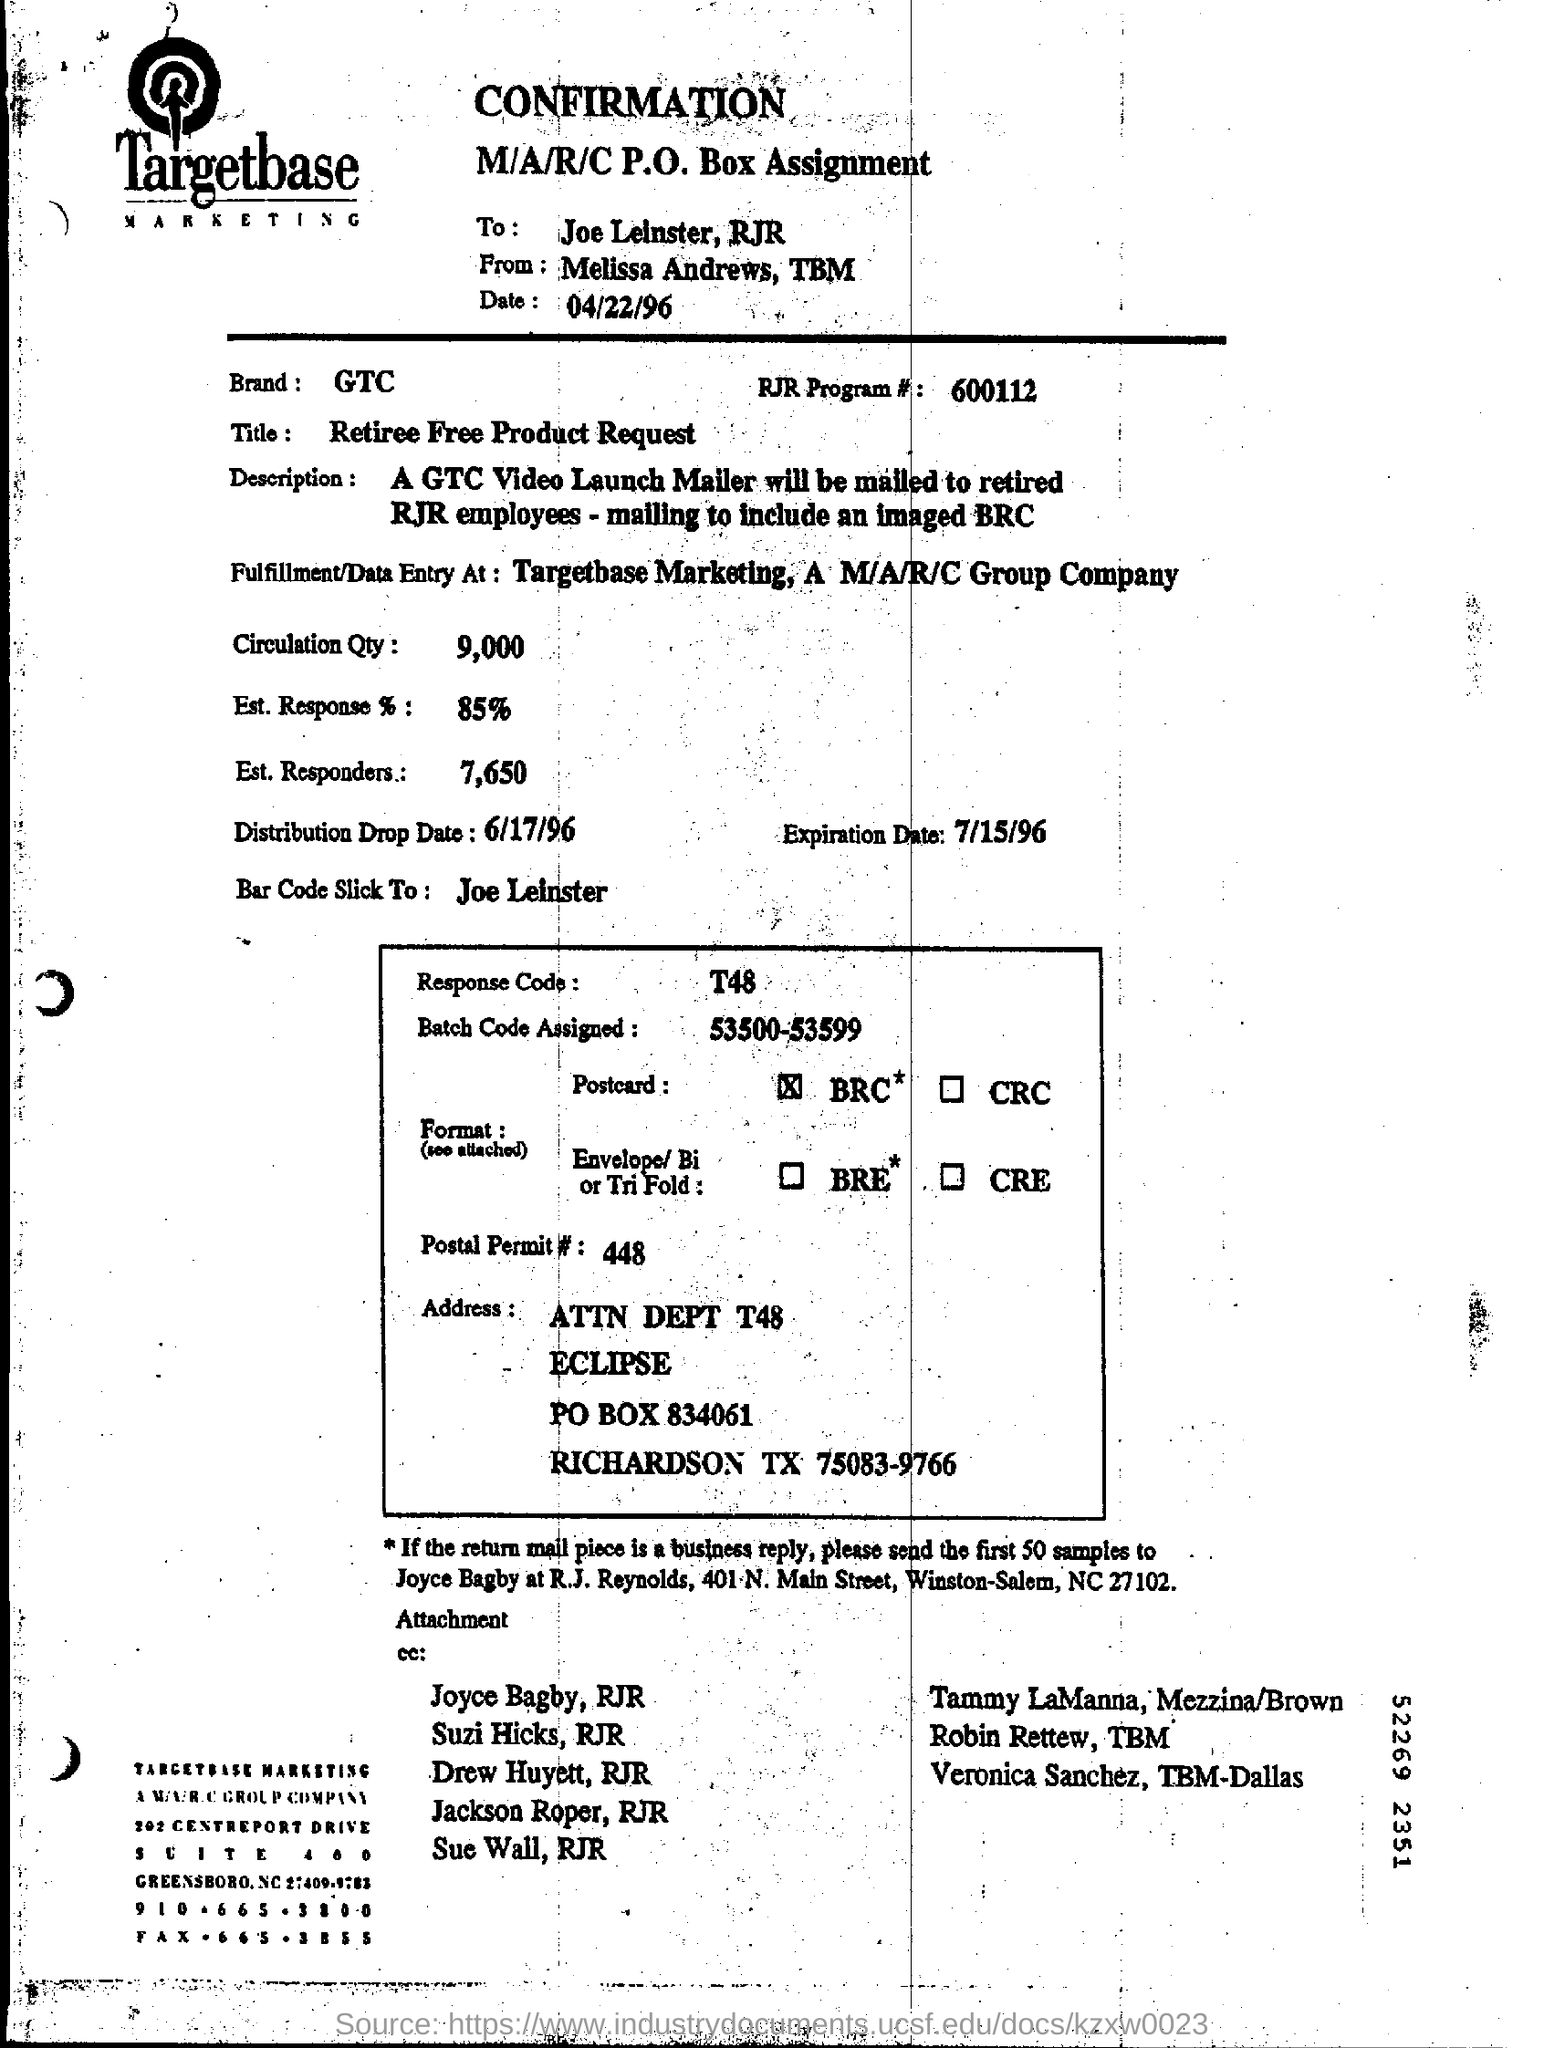Mention a couple of crucial points in this snapshot. The title of this text is 'What is the Title? retiree free product request...' The RJR Program number is 600112, as denoted by the series of digits and letters comprising the unique identifier. The Postal Permit number is 448. The estimated response rate is expected to be 85%. The circulation quantity is 9,000. 